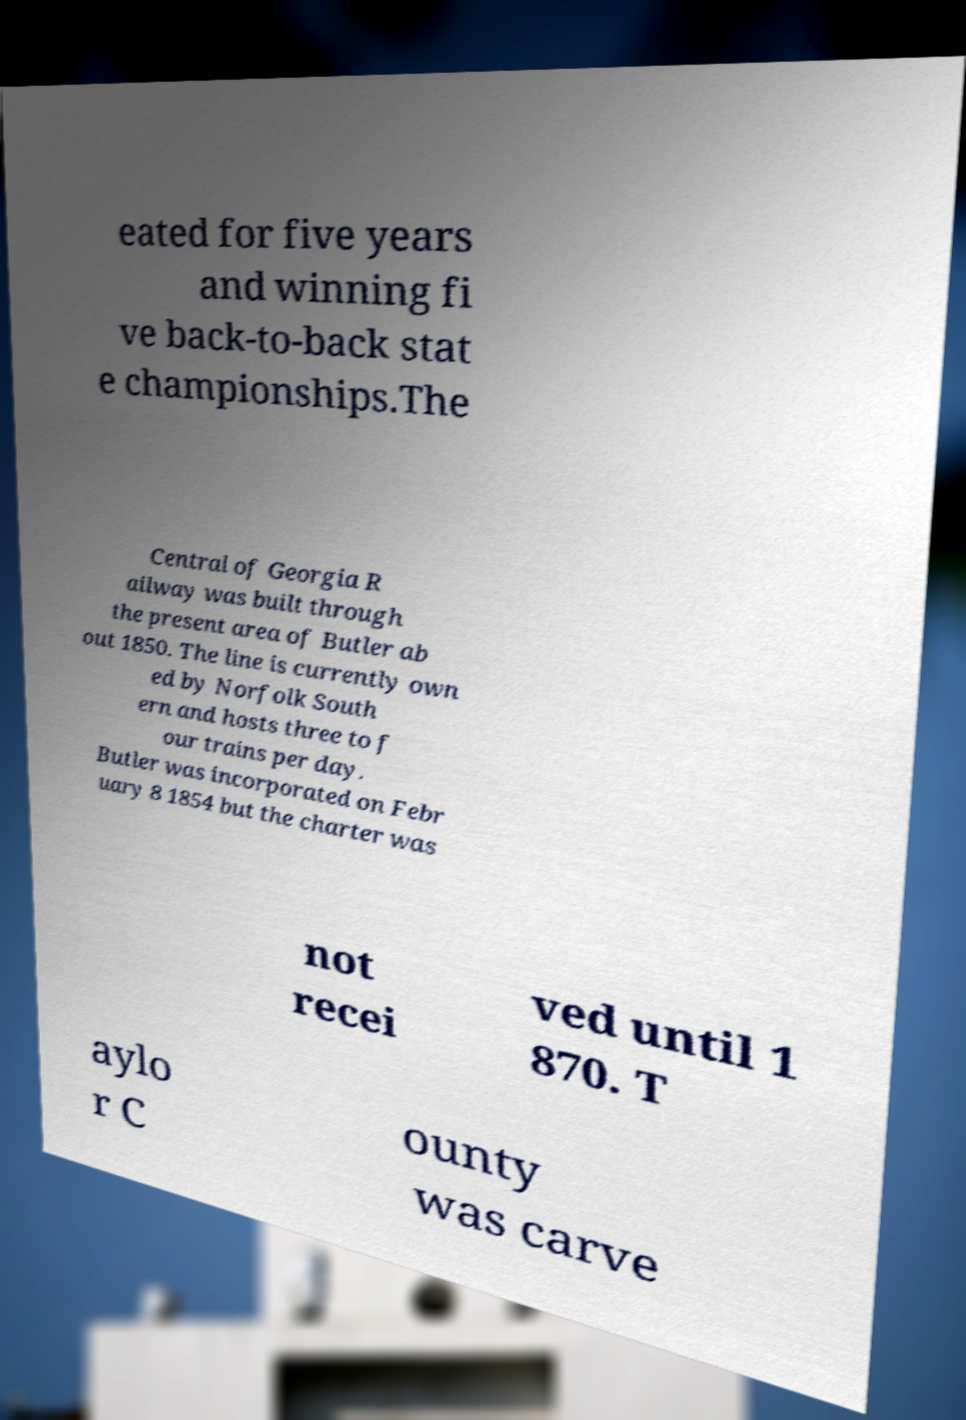Can you accurately transcribe the text from the provided image for me? eated for five years and winning fi ve back-to-back stat e championships.The Central of Georgia R ailway was built through the present area of Butler ab out 1850. The line is currently own ed by Norfolk South ern and hosts three to f our trains per day. Butler was incorporated on Febr uary 8 1854 but the charter was not recei ved until 1 870. T aylo r C ounty was carve 